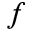<formula> <loc_0><loc_0><loc_500><loc_500>f</formula> 